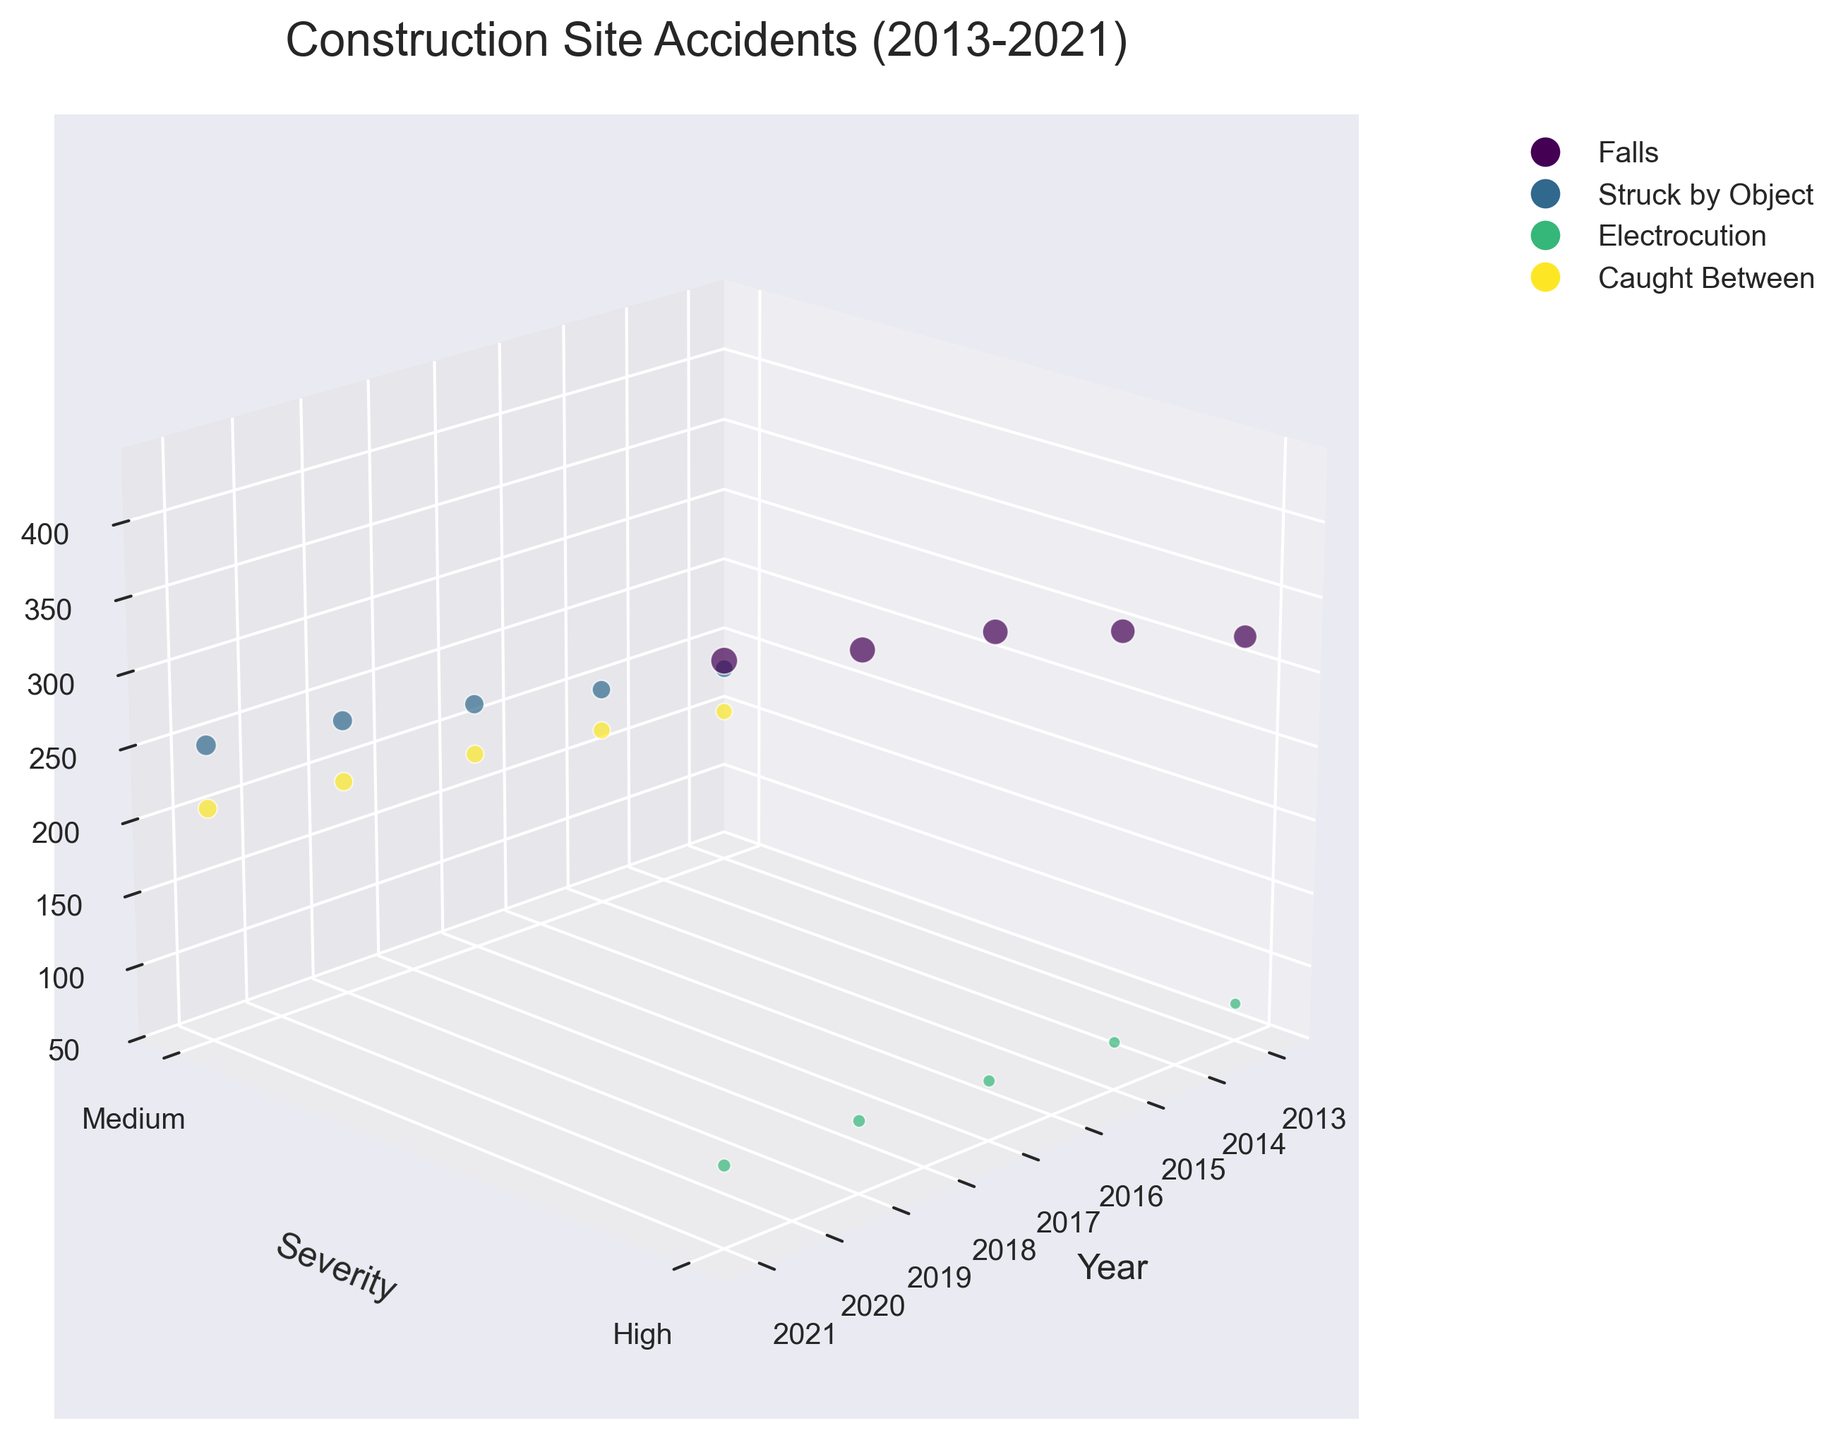what's the title of the figure? The title is typically displayed at the top of the figure. In this case, it is clearly mentioned in the code to be 'Construction Site Accidents (2013-2021)'.
Answer: Construction Site Accidents (2013-2021) how many types of accidents are shown in the figure? The legend elements represent each type of accident, which are 'Falls', 'Struck by Object', 'Electrocution', and 'Caught Between'. These elements can be visually distinguished by different colors used for the bubbles.
Answer: 4 which accident type has the highest frequency in 2021? By looking at the data points for 2021, we find the bubbles at the 2021 mark on the x-axis. The largest bubble in 2021 corresponds to 'Falls'.
Answer: Falls how does the frequency of 'Electrocution' accidents change from 2013 to 2021? To understand the trend, we look at the 'Electrocution' data points on the x-axis corresponding to 2013, 2015, 2017, 2019, and 2021. The frequencies increase from 74 to 81, 89, 97, and finally 103. Thus, there is a consistent increase over the years.
Answer: It increases which severity level has more accidents in 2019, 'Medium' or 'High'? By examining the y-axis and comparing the combined frequencies of accidents in 2019 with 'Medium' severity ('Struck by Object' and 'Caught Between') against those of 'High' severity ('Falls' and 'Electrocution'), we see 'High' severity (498 combined) is higher than 'Medium' (434 combined).
Answer: High for 'Struck by Object' accidents, how does the frequency in 2015 compare to 2021? We compare the size of the bubbles for 'Struck by Object' in 2015 and 2021. The frequency increases from 201 in 2015 to 251 in 2021, indicating a rise.
Answer: It increases what is the year with the highest overall frequency of 'Caught Between' accidents? By locating the 'Caught Between' data points and comparing their frequencies, the highest frequency is in 2021 with 208.
Answer: 2021 what is the color representation for 'Falls' in the figure? According to the first 'for' loop that assigns colors, each type of accident is given a unique color. The color for 'Falls' is identified from the bubble using the visual legend.
Answer: color near green how many high severity 'Falls' accidents occurred in 2017? The frequency of high severity 'Falls' accidents in 2017 can be directly read from the bubble corresponding to 'Falls' in 2017, which is 384.
Answer: 384 which two years have the maximum increase in 'Medium' severity 'Caught Between' accidents? By observing the frequency values for 'Caught Between' across years, the largest increase happens from 172 in 2015 to 185 in 2017 and finally to 196 in 2019. The critical increase is more noticeable between the two closest values: between 2017 and 2019.
Answer: 2017 to 2019 